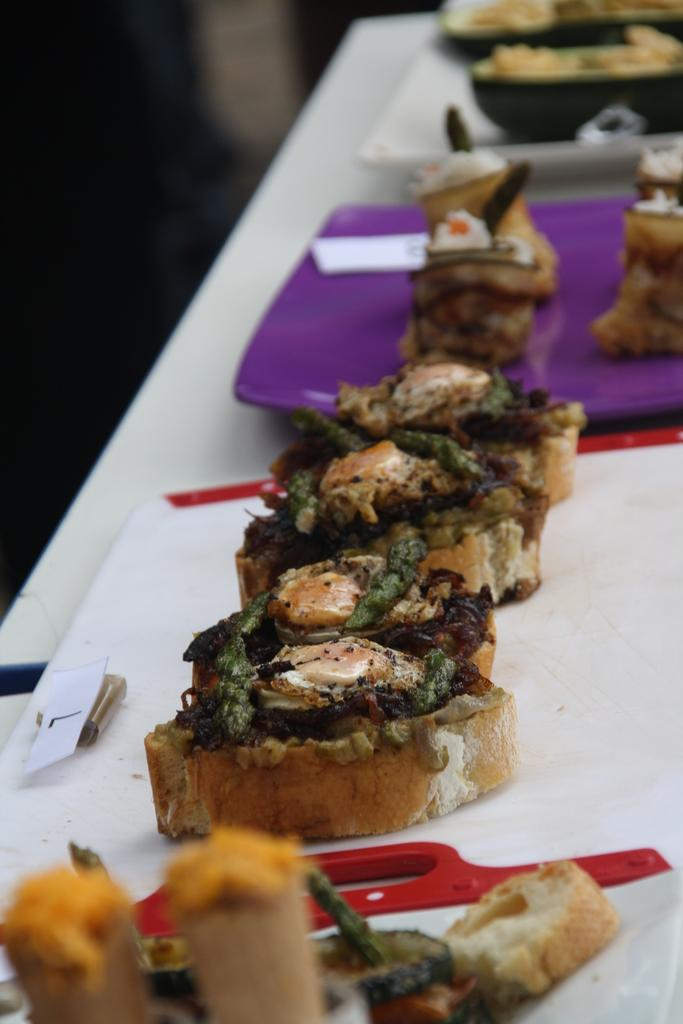What is: What is on the plates in the image? There are food items on the plates in the image. Where are the plates located? The plates are on an object, possibly a table, in the image. What can be seen in the background of the image? The background of the image is blurred. What type of appliance is being used in the battle depicted in the image? There is no battle or appliance present in the image. 